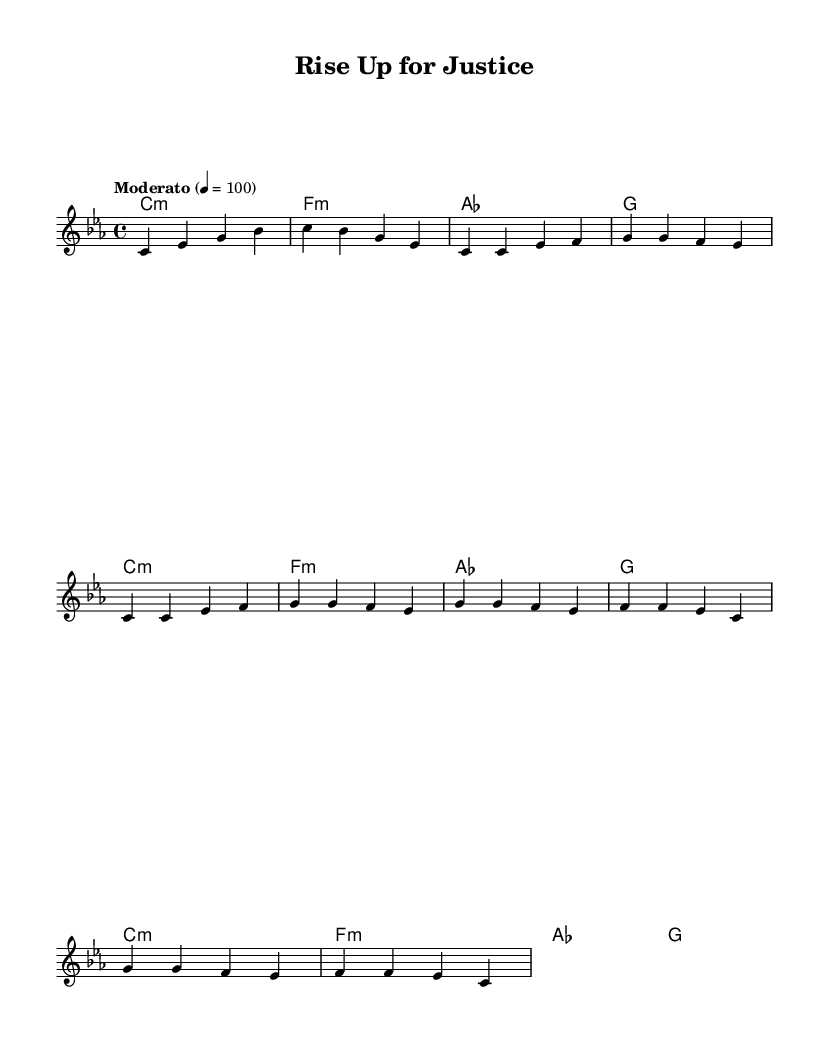What is the key signature of this music? The key signature is C minor, which has three flats (B flat, E flat, and A flat). This is indicated by the 'c' in the opening of the global section.
Answer: C minor What is the time signature of this piece? The time signature is 4/4, which means there are four beats in each measure and a quarter note receives one beat. This is clearly stated at the beginning of the global section.
Answer: 4/4 What is the tempo marking? The tempo marking is "Moderato," which indicates a moderate speed for this piece. It is set to 100 beats per minute, as shown at the top of the score.
Answer: Moderato How many measures does the chorus consist of? The chorus is made up of 4 measures, which is evident by counting the measures in the chorus section listed in the melody.
Answer: 4 measures What is the primary theme of the lyrics in the verse? The primary theme of the verse lyrics revolves around fear and uncertainty while walking the streets, reflecting experiences related to racial inequality. This idea is conveyed through the specific words chosen in the lyrical content of the verse.
Answer: Fear and uncertainty Why is the title significant in relation to the song’s message? The title "Rise Up for Justice" signifies a call to action and empowerment, aligning with the themes of social justice and equality present in the lyrics, particularly in the chorus where it encourages fighting for what's right.
Answer: A call to action 